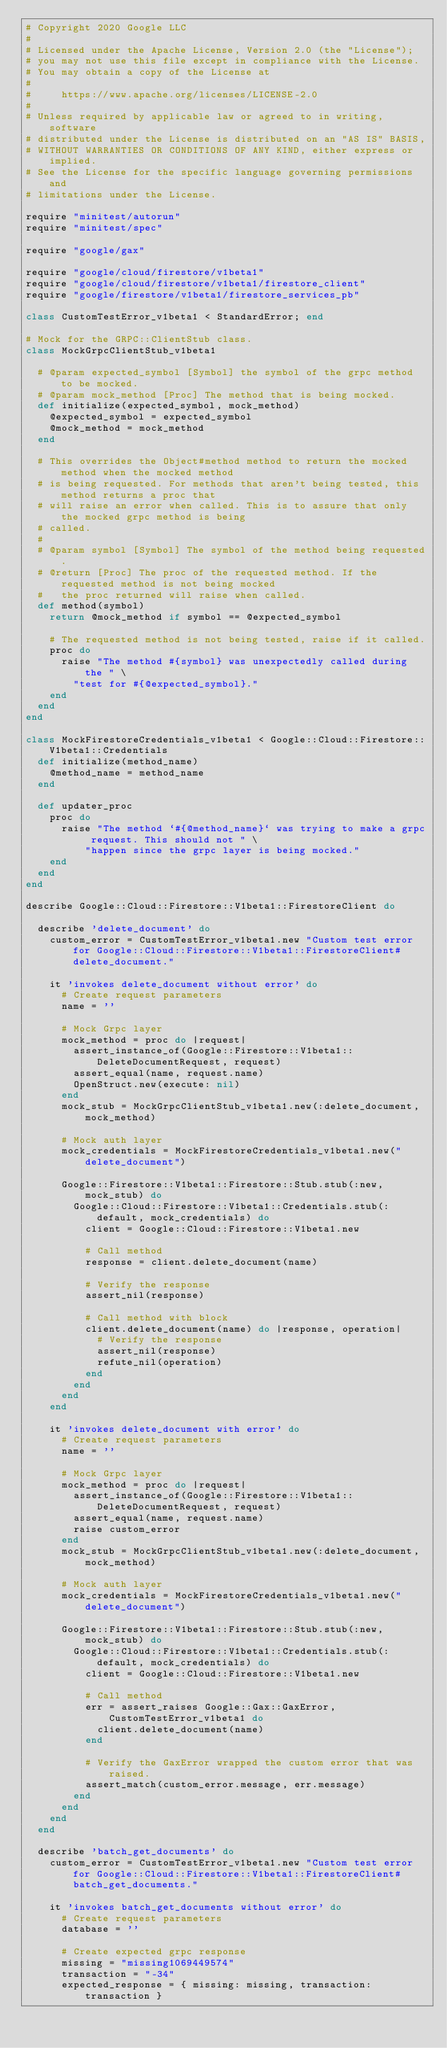<code> <loc_0><loc_0><loc_500><loc_500><_Ruby_># Copyright 2020 Google LLC
#
# Licensed under the Apache License, Version 2.0 (the "License");
# you may not use this file except in compliance with the License.
# You may obtain a copy of the License at
#
#     https://www.apache.org/licenses/LICENSE-2.0
#
# Unless required by applicable law or agreed to in writing, software
# distributed under the License is distributed on an "AS IS" BASIS,
# WITHOUT WARRANTIES OR CONDITIONS OF ANY KIND, either express or implied.
# See the License for the specific language governing permissions and
# limitations under the License.

require "minitest/autorun"
require "minitest/spec"

require "google/gax"

require "google/cloud/firestore/v1beta1"
require "google/cloud/firestore/v1beta1/firestore_client"
require "google/firestore/v1beta1/firestore_services_pb"

class CustomTestError_v1beta1 < StandardError; end

# Mock for the GRPC::ClientStub class.
class MockGrpcClientStub_v1beta1

  # @param expected_symbol [Symbol] the symbol of the grpc method to be mocked.
  # @param mock_method [Proc] The method that is being mocked.
  def initialize(expected_symbol, mock_method)
    @expected_symbol = expected_symbol
    @mock_method = mock_method
  end

  # This overrides the Object#method method to return the mocked method when the mocked method
  # is being requested. For methods that aren't being tested, this method returns a proc that
  # will raise an error when called. This is to assure that only the mocked grpc method is being
  # called.
  #
  # @param symbol [Symbol] The symbol of the method being requested.
  # @return [Proc] The proc of the requested method. If the requested method is not being mocked
  #   the proc returned will raise when called.
  def method(symbol)
    return @mock_method if symbol == @expected_symbol

    # The requested method is not being tested, raise if it called.
    proc do
      raise "The method #{symbol} was unexpectedly called during the " \
        "test for #{@expected_symbol}."
    end
  end
end

class MockFirestoreCredentials_v1beta1 < Google::Cloud::Firestore::V1beta1::Credentials
  def initialize(method_name)
    @method_name = method_name
  end

  def updater_proc
    proc do
      raise "The method `#{@method_name}` was trying to make a grpc request. This should not " \
          "happen since the grpc layer is being mocked."
    end
  end
end

describe Google::Cloud::Firestore::V1beta1::FirestoreClient do

  describe 'delete_document' do
    custom_error = CustomTestError_v1beta1.new "Custom test error for Google::Cloud::Firestore::V1beta1::FirestoreClient#delete_document."

    it 'invokes delete_document without error' do
      # Create request parameters
      name = ''

      # Mock Grpc layer
      mock_method = proc do |request|
        assert_instance_of(Google::Firestore::V1beta1::DeleteDocumentRequest, request)
        assert_equal(name, request.name)
        OpenStruct.new(execute: nil)
      end
      mock_stub = MockGrpcClientStub_v1beta1.new(:delete_document, mock_method)

      # Mock auth layer
      mock_credentials = MockFirestoreCredentials_v1beta1.new("delete_document")

      Google::Firestore::V1beta1::Firestore::Stub.stub(:new, mock_stub) do
        Google::Cloud::Firestore::V1beta1::Credentials.stub(:default, mock_credentials) do
          client = Google::Cloud::Firestore::V1beta1.new

          # Call method
          response = client.delete_document(name)

          # Verify the response
          assert_nil(response)

          # Call method with block
          client.delete_document(name) do |response, operation|
            # Verify the response
            assert_nil(response)
            refute_nil(operation)
          end
        end
      end
    end

    it 'invokes delete_document with error' do
      # Create request parameters
      name = ''

      # Mock Grpc layer
      mock_method = proc do |request|
        assert_instance_of(Google::Firestore::V1beta1::DeleteDocumentRequest, request)
        assert_equal(name, request.name)
        raise custom_error
      end
      mock_stub = MockGrpcClientStub_v1beta1.new(:delete_document, mock_method)

      # Mock auth layer
      mock_credentials = MockFirestoreCredentials_v1beta1.new("delete_document")

      Google::Firestore::V1beta1::Firestore::Stub.stub(:new, mock_stub) do
        Google::Cloud::Firestore::V1beta1::Credentials.stub(:default, mock_credentials) do
          client = Google::Cloud::Firestore::V1beta1.new

          # Call method
          err = assert_raises Google::Gax::GaxError, CustomTestError_v1beta1 do
            client.delete_document(name)
          end

          # Verify the GaxError wrapped the custom error that was raised.
          assert_match(custom_error.message, err.message)
        end
      end
    end
  end

  describe 'batch_get_documents' do
    custom_error = CustomTestError_v1beta1.new "Custom test error for Google::Cloud::Firestore::V1beta1::FirestoreClient#batch_get_documents."

    it 'invokes batch_get_documents without error' do
      # Create request parameters
      database = ''

      # Create expected grpc response
      missing = "missing1069449574"
      transaction = "-34"
      expected_response = { missing: missing, transaction: transaction }</code> 